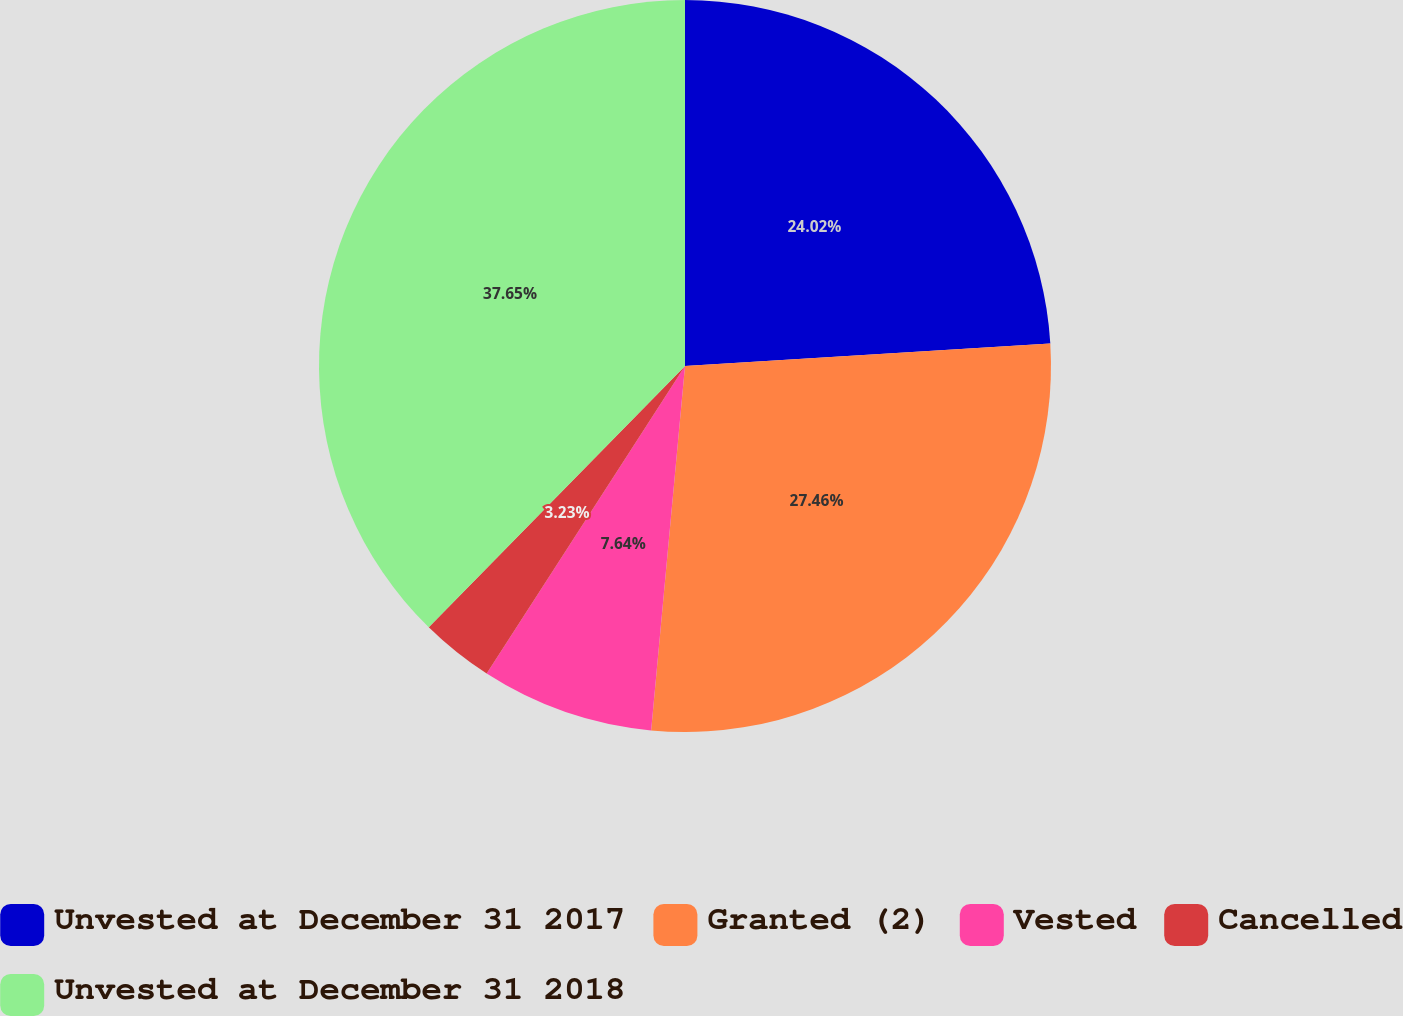Convert chart to OTSL. <chart><loc_0><loc_0><loc_500><loc_500><pie_chart><fcel>Unvested at December 31 2017<fcel>Granted (2)<fcel>Vested<fcel>Cancelled<fcel>Unvested at December 31 2018<nl><fcel>24.02%<fcel>27.46%<fcel>7.64%<fcel>3.23%<fcel>37.66%<nl></chart> 